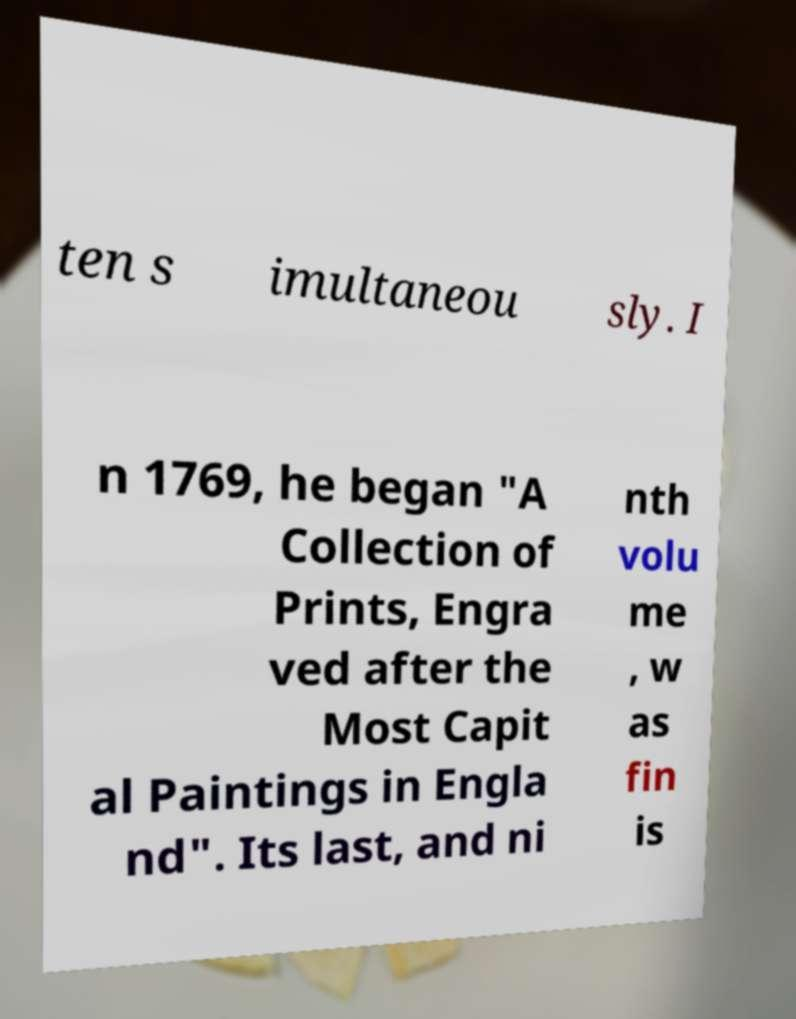Could you extract and type out the text from this image? ten s imultaneou sly. I n 1769, he began "A Collection of Prints, Engra ved after the Most Capit al Paintings in Engla nd". Its last, and ni nth volu me , w as fin is 